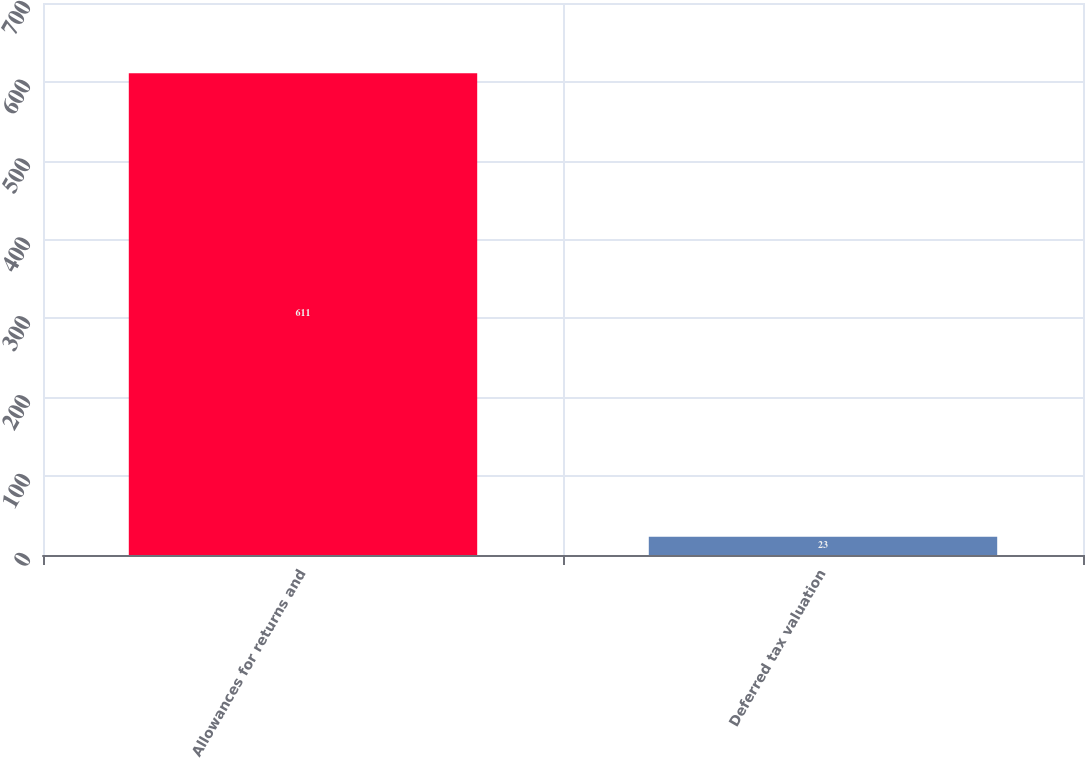<chart> <loc_0><loc_0><loc_500><loc_500><bar_chart><fcel>Allowances for returns and<fcel>Deferred tax valuation<nl><fcel>611<fcel>23<nl></chart> 